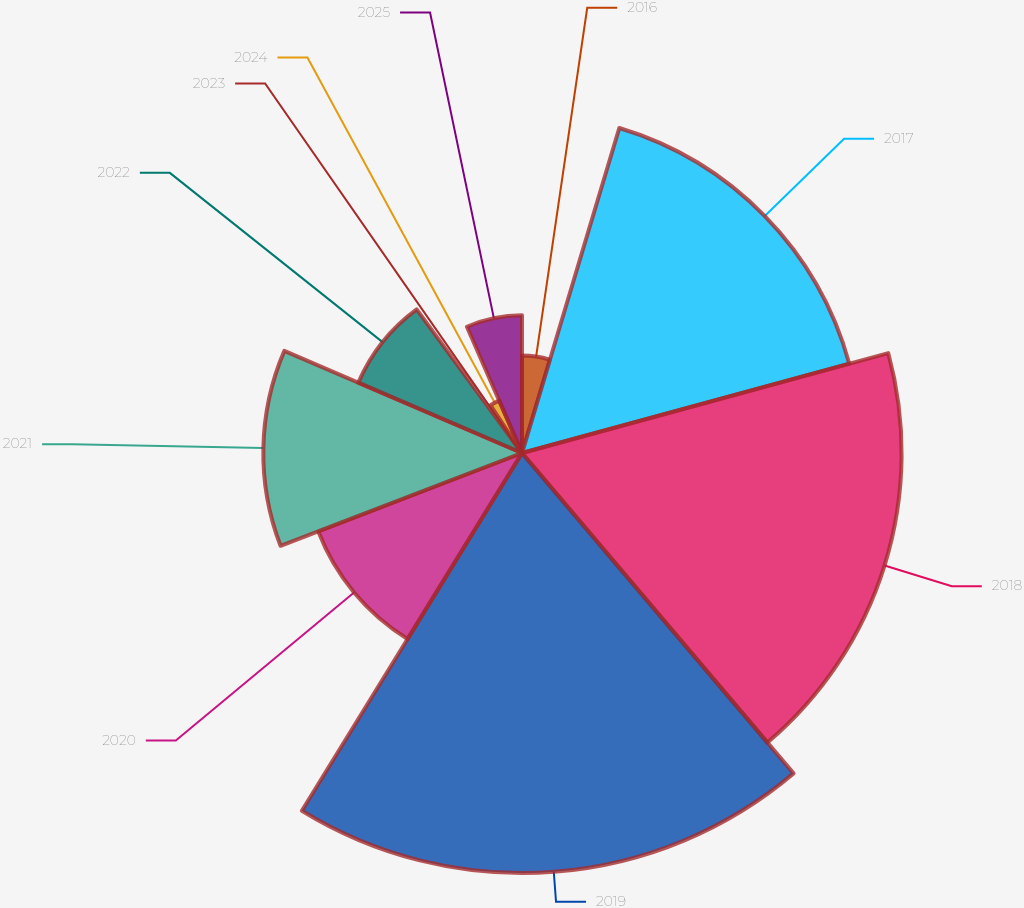Convert chart to OTSL. <chart><loc_0><loc_0><loc_500><loc_500><pie_chart><fcel>2016<fcel>2017<fcel>2018<fcel>2019<fcel>2020<fcel>2021<fcel>2022<fcel>2023<fcel>2024<fcel>2025<nl><fcel>4.63%<fcel>16.13%<fcel>18.05%<fcel>19.97%<fcel>10.38%<fcel>12.3%<fcel>8.47%<fcel>0.8%<fcel>2.72%<fcel>6.55%<nl></chart> 